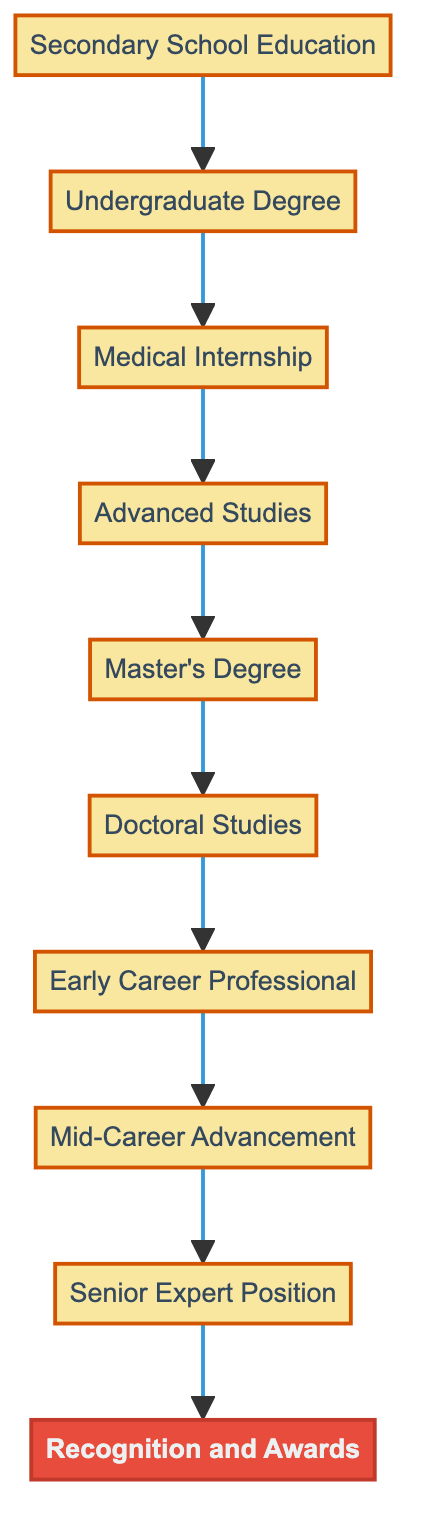What is the first step in the career path? The diagram shows that the first step is "Secondary School Education," which is the foundation for further education.
Answer: Secondary School Education How many nodes are in the diagram? By counting each distinct step or milestone in the diagram, there are a total of ten nodes listed in the elements.
Answer: Ten What follows the Medical Internship? The diagram indicates that after the "Medical Internship," the next step is "Advanced Studies," representing further specialization in the field.
Answer: Advanced Studies Which milestone is represented at the top of the diagram? The diagram reveals that the final milestone, located at the top, is "Recognition and Awards," highlighting the end goal of a public health professional's journey.
Answer: Recognition and Awards In what order do the educational components occur before entering a career? Analyzing the flow from bottom to top, the components are arranged as "Secondary School Education," "Undergraduate Degree," "Medical Internship," "Advanced Studies," "Master's Degree," and "Doctoral Studies" before entering the career path.
Answer: Secondary School Education, Undergraduate Degree, Medical Internship, Advanced Studies, Master's Degree, Doctoral Studies What is the primary focus of the "Advanced Studies" step? According to the diagram, the "Advanced Studies" focuses on pursuing a specialization in "Epidemiology or Public Health," which is a crucial aspect of the educational journey.
Answer: Epidemiology or Public Health What type of roles are included in the "Early Career Professional" step? The diagram specifies that this step includes roles such as "public health officer" or "epidemiologist," which are initial professional positions in public health.
Answer: Public health officer, epidemiologist What does the "Senior Expert Position" involve according to the flow? The diagram illustrates that the "Senior Expert Position" involves serving as a senior advisor or head of a national public health program, with an emphasis on policy development.
Answer: Senior advisor, head of a national public health program How does one progress from "Early Career Professional" to "Mid-Career Advancement"? The diagram indicates that the progression from "Early Career Professional" to "Mid-Career Advancement" is achieved through promotion, reflecting growth and increased responsibility in the public health domain.
Answer: Promotion 